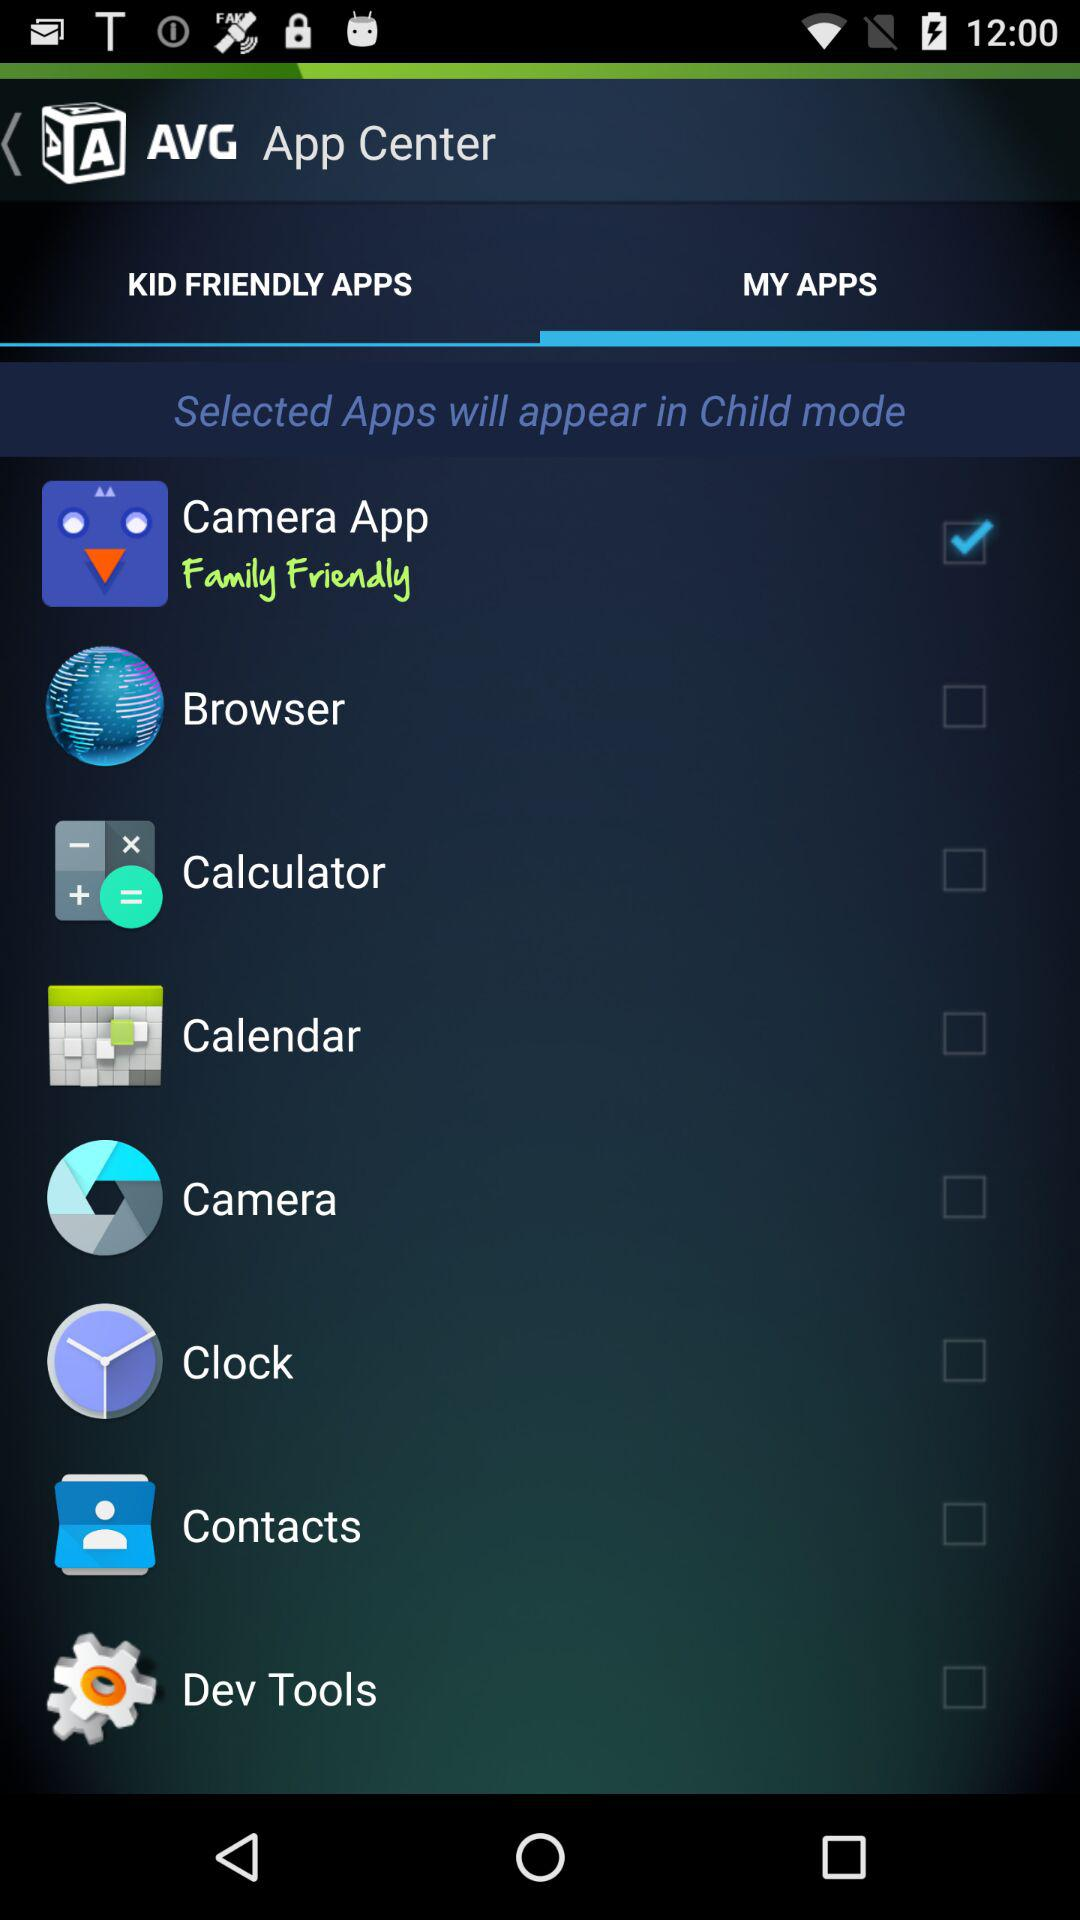Which option is selected? The selected option is "Camera App". 